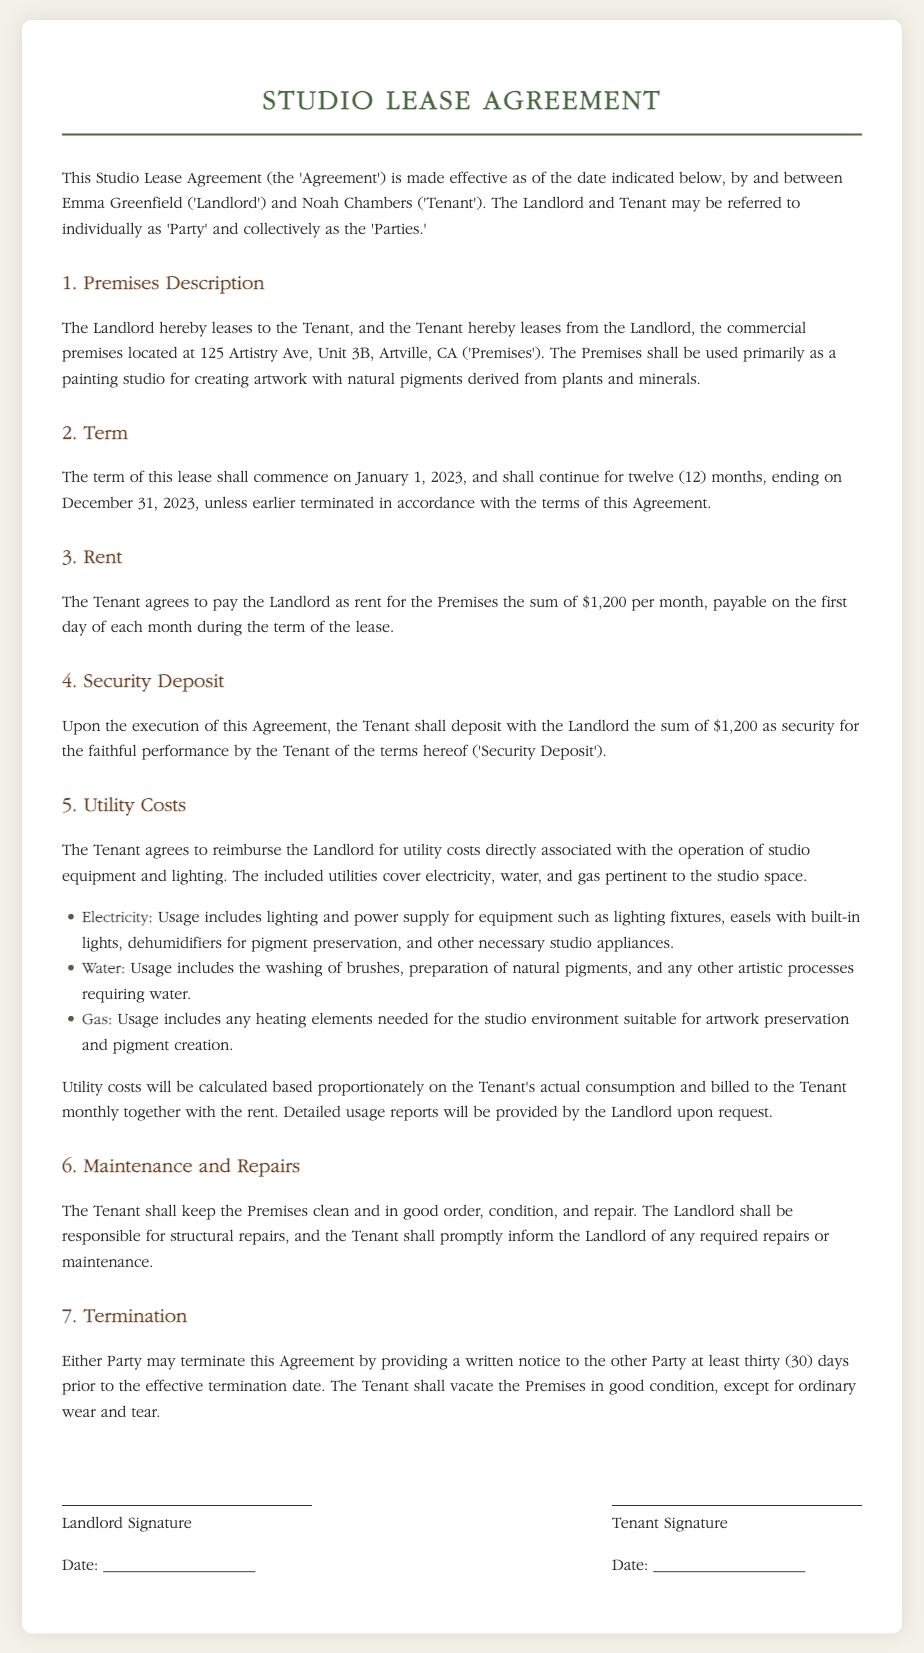What is the address of the Premises? The address of the Premises is explicitly stated as 125 Artistry Ave, Unit 3B, Artville, CA.
Answer: 125 Artistry Ave, Unit 3B, Artville, CA Who is the Tenant? The Tenant is identified in the document as Noah Chambers.
Answer: Noah Chambers What is the monthly rent amount? The rent amount for the Premises is explicitly stated as $1,200 per month.
Answer: $1,200 What utilities must the Tenant reimburse the Landlord for? The document lists utilities which include electricity, water, and gas.
Answer: Electricity, water, and gas When does the lease term begin? The lease term is stated to commence on January 1, 2023.
Answer: January 1, 2023 What is the duration of the lease? The lease is specified to last for twelve months, until December 31, 2023.
Answer: Twelve months How is the utility cost calculated? The utility cost will be calculated based proportionately on the Tenant's actual consumption.
Answer: Proportionately on actual consumption What must the Tenant do before ending the Agreement? The Tenant must provide written notice at least thirty days prior to the termination date.
Answer: Provide written notice thirty days prior Who is responsible for structural repairs? The document states that the Landlord shall be responsible for structural repairs.
Answer: Landlord 